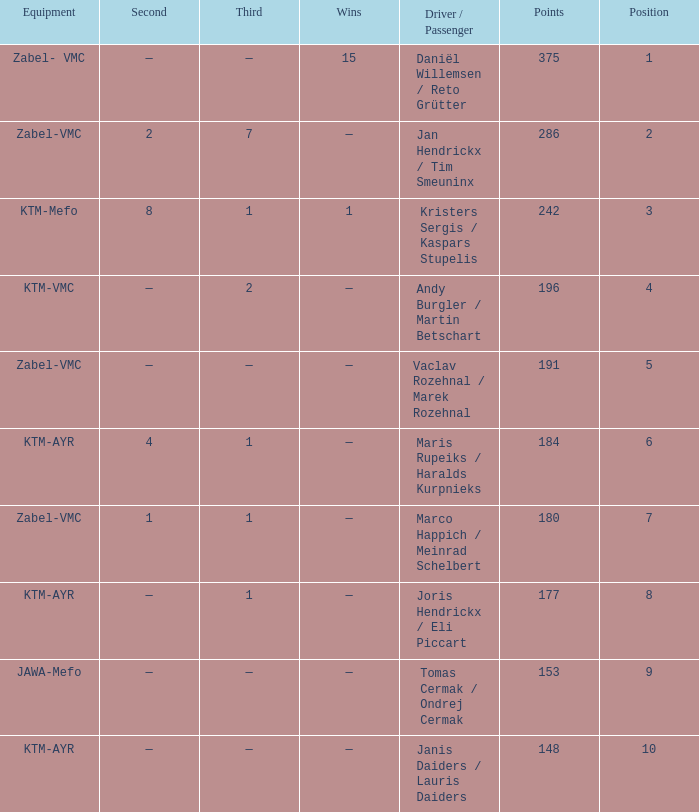Who was the driver/passengar when the position was smaller than 8, the third was 1, and there was 1 win? Kristers Sergis / Kaspars Stupelis. 